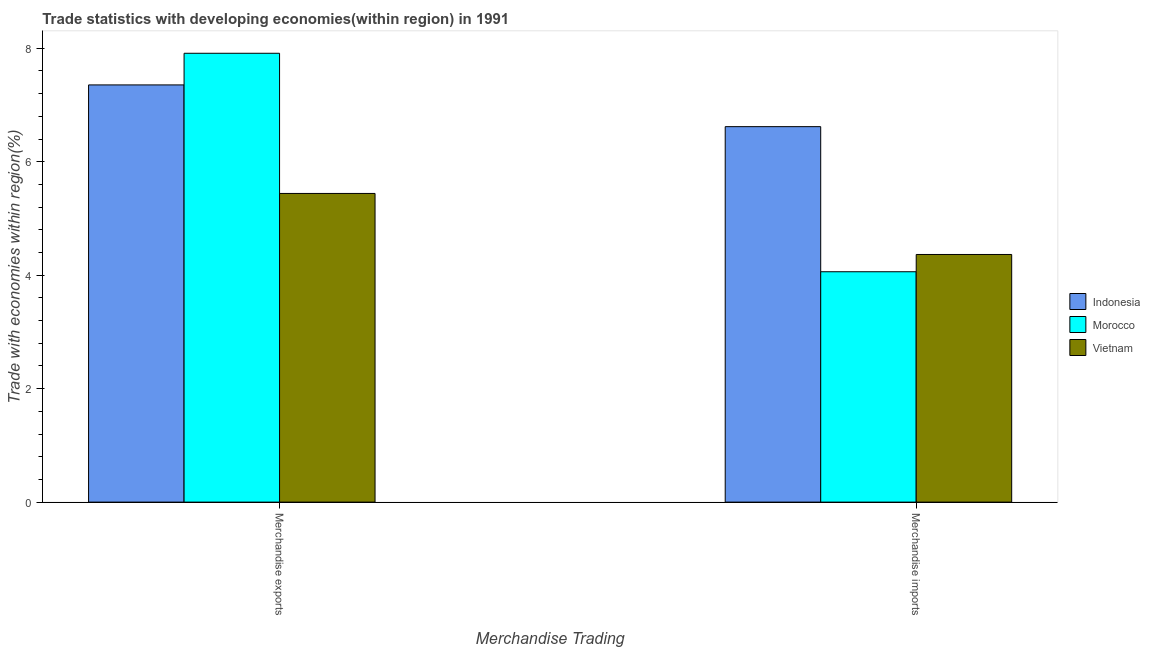Are the number of bars per tick equal to the number of legend labels?
Your answer should be very brief. Yes. How many bars are there on the 2nd tick from the right?
Ensure brevity in your answer.  3. What is the merchandise exports in Indonesia?
Provide a short and direct response. 7.35. Across all countries, what is the maximum merchandise imports?
Your response must be concise. 6.62. Across all countries, what is the minimum merchandise exports?
Your answer should be very brief. 5.44. In which country was the merchandise exports maximum?
Ensure brevity in your answer.  Morocco. In which country was the merchandise imports minimum?
Ensure brevity in your answer.  Morocco. What is the total merchandise imports in the graph?
Provide a succinct answer. 15.05. What is the difference between the merchandise exports in Vietnam and that in Indonesia?
Your response must be concise. -1.91. What is the difference between the merchandise exports in Vietnam and the merchandise imports in Morocco?
Give a very brief answer. 1.38. What is the average merchandise exports per country?
Give a very brief answer. 6.9. What is the difference between the merchandise imports and merchandise exports in Morocco?
Keep it short and to the point. -3.85. In how many countries, is the merchandise exports greater than 5.2 %?
Offer a terse response. 3. What is the ratio of the merchandise imports in Indonesia to that in Vietnam?
Keep it short and to the point. 1.52. Is the merchandise exports in Indonesia less than that in Vietnam?
Your response must be concise. No. In how many countries, is the merchandise imports greater than the average merchandise imports taken over all countries?
Provide a succinct answer. 1. What does the 2nd bar from the left in Merchandise exports represents?
Keep it short and to the point. Morocco. What does the 2nd bar from the right in Merchandise exports represents?
Make the answer very short. Morocco. How many bars are there?
Provide a short and direct response. 6. How many countries are there in the graph?
Make the answer very short. 3. What is the difference between two consecutive major ticks on the Y-axis?
Your answer should be compact. 2. How are the legend labels stacked?
Your response must be concise. Vertical. What is the title of the graph?
Your answer should be compact. Trade statistics with developing economies(within region) in 1991. What is the label or title of the X-axis?
Provide a succinct answer. Merchandise Trading. What is the label or title of the Y-axis?
Your answer should be very brief. Trade with economies within region(%). What is the Trade with economies within region(%) in Indonesia in Merchandise exports?
Keep it short and to the point. 7.35. What is the Trade with economies within region(%) of Morocco in Merchandise exports?
Make the answer very short. 7.91. What is the Trade with economies within region(%) in Vietnam in Merchandise exports?
Your answer should be very brief. 5.44. What is the Trade with economies within region(%) in Indonesia in Merchandise imports?
Offer a terse response. 6.62. What is the Trade with economies within region(%) of Morocco in Merchandise imports?
Offer a very short reply. 4.06. What is the Trade with economies within region(%) of Vietnam in Merchandise imports?
Make the answer very short. 4.37. Across all Merchandise Trading, what is the maximum Trade with economies within region(%) of Indonesia?
Ensure brevity in your answer.  7.35. Across all Merchandise Trading, what is the maximum Trade with economies within region(%) of Morocco?
Provide a short and direct response. 7.91. Across all Merchandise Trading, what is the maximum Trade with economies within region(%) in Vietnam?
Make the answer very short. 5.44. Across all Merchandise Trading, what is the minimum Trade with economies within region(%) of Indonesia?
Offer a very short reply. 6.62. Across all Merchandise Trading, what is the minimum Trade with economies within region(%) of Morocco?
Your answer should be very brief. 4.06. Across all Merchandise Trading, what is the minimum Trade with economies within region(%) of Vietnam?
Provide a short and direct response. 4.37. What is the total Trade with economies within region(%) in Indonesia in the graph?
Offer a terse response. 13.97. What is the total Trade with economies within region(%) of Morocco in the graph?
Your answer should be compact. 11.97. What is the total Trade with economies within region(%) of Vietnam in the graph?
Offer a very short reply. 9.81. What is the difference between the Trade with economies within region(%) of Indonesia in Merchandise exports and that in Merchandise imports?
Make the answer very short. 0.74. What is the difference between the Trade with economies within region(%) in Morocco in Merchandise exports and that in Merchandise imports?
Offer a terse response. 3.85. What is the difference between the Trade with economies within region(%) of Vietnam in Merchandise exports and that in Merchandise imports?
Offer a terse response. 1.08. What is the difference between the Trade with economies within region(%) in Indonesia in Merchandise exports and the Trade with economies within region(%) in Morocco in Merchandise imports?
Your answer should be compact. 3.29. What is the difference between the Trade with economies within region(%) of Indonesia in Merchandise exports and the Trade with economies within region(%) of Vietnam in Merchandise imports?
Provide a short and direct response. 2.99. What is the difference between the Trade with economies within region(%) of Morocco in Merchandise exports and the Trade with economies within region(%) of Vietnam in Merchandise imports?
Provide a succinct answer. 3.55. What is the average Trade with economies within region(%) of Indonesia per Merchandise Trading?
Ensure brevity in your answer.  6.99. What is the average Trade with economies within region(%) of Morocco per Merchandise Trading?
Your answer should be compact. 5.99. What is the average Trade with economies within region(%) in Vietnam per Merchandise Trading?
Your answer should be very brief. 4.9. What is the difference between the Trade with economies within region(%) of Indonesia and Trade with economies within region(%) of Morocco in Merchandise exports?
Your answer should be compact. -0.56. What is the difference between the Trade with economies within region(%) in Indonesia and Trade with economies within region(%) in Vietnam in Merchandise exports?
Ensure brevity in your answer.  1.91. What is the difference between the Trade with economies within region(%) in Morocco and Trade with economies within region(%) in Vietnam in Merchandise exports?
Offer a terse response. 2.47. What is the difference between the Trade with economies within region(%) in Indonesia and Trade with economies within region(%) in Morocco in Merchandise imports?
Provide a succinct answer. 2.56. What is the difference between the Trade with economies within region(%) of Indonesia and Trade with economies within region(%) of Vietnam in Merchandise imports?
Offer a very short reply. 2.25. What is the difference between the Trade with economies within region(%) in Morocco and Trade with economies within region(%) in Vietnam in Merchandise imports?
Offer a very short reply. -0.3. What is the ratio of the Trade with economies within region(%) in Morocco in Merchandise exports to that in Merchandise imports?
Keep it short and to the point. 1.95. What is the ratio of the Trade with economies within region(%) of Vietnam in Merchandise exports to that in Merchandise imports?
Provide a succinct answer. 1.25. What is the difference between the highest and the second highest Trade with economies within region(%) in Indonesia?
Your response must be concise. 0.74. What is the difference between the highest and the second highest Trade with economies within region(%) of Morocco?
Offer a very short reply. 3.85. What is the difference between the highest and the second highest Trade with economies within region(%) in Vietnam?
Keep it short and to the point. 1.08. What is the difference between the highest and the lowest Trade with economies within region(%) in Indonesia?
Your answer should be compact. 0.74. What is the difference between the highest and the lowest Trade with economies within region(%) of Morocco?
Your response must be concise. 3.85. What is the difference between the highest and the lowest Trade with economies within region(%) in Vietnam?
Offer a terse response. 1.08. 